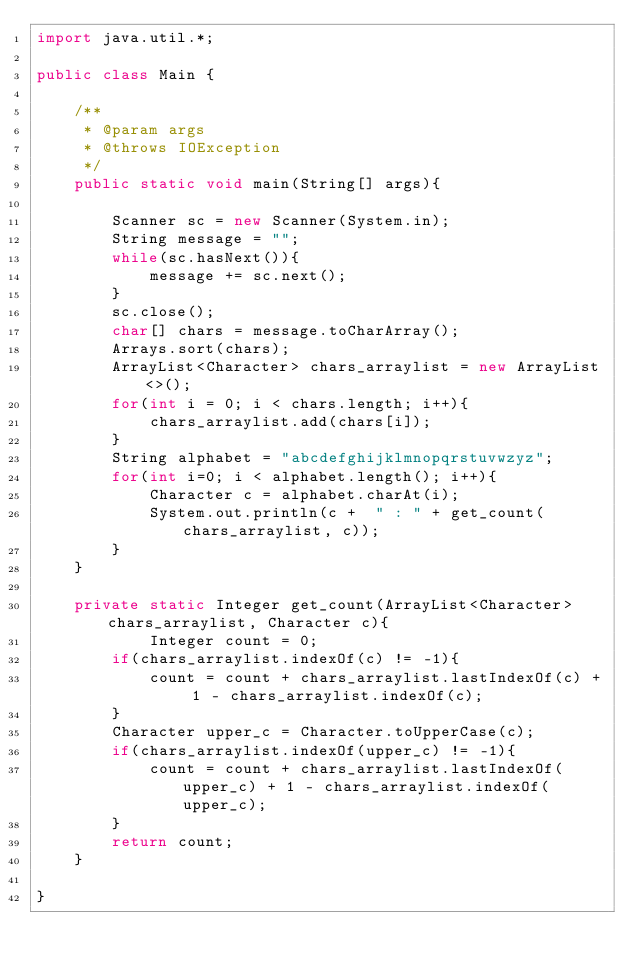Convert code to text. <code><loc_0><loc_0><loc_500><loc_500><_Java_>import java.util.*;

public class Main {

	/**
	 * @param args
	 * @throws IOException 
	 */
	public static void main(String[] args){

		Scanner sc = new Scanner(System.in);
		String message = "";
		while(sc.hasNext()){
			message += sc.next();
		}
		sc.close();
		char[] chars = message.toCharArray();
		Arrays.sort(chars);
		ArrayList<Character> chars_arraylist = new ArrayList<>();
		for(int i = 0; i < chars.length; i++){
			chars_arraylist.add(chars[i]);
		}
		String alphabet = "abcdefghijklmnopqrstuvwzyz";
		for(int i=0; i < alphabet.length(); i++){
			Character c = alphabet.charAt(i);
			System.out.println(c +  " : " + get_count(chars_arraylist, c));
		}
	}

	private static Integer get_count(ArrayList<Character> chars_arraylist, Character c){
			Integer count = 0;
		if(chars_arraylist.indexOf(c) != -1){
			count = count + chars_arraylist.lastIndexOf(c) + 1 - chars_arraylist.indexOf(c);
		}
		Character upper_c = Character.toUpperCase(c);
		if(chars_arraylist.indexOf(upper_c) != -1){
			count = count + chars_arraylist.lastIndexOf(upper_c) + 1 - chars_arraylist.indexOf(upper_c);
		}
		return count;
	}

}</code> 